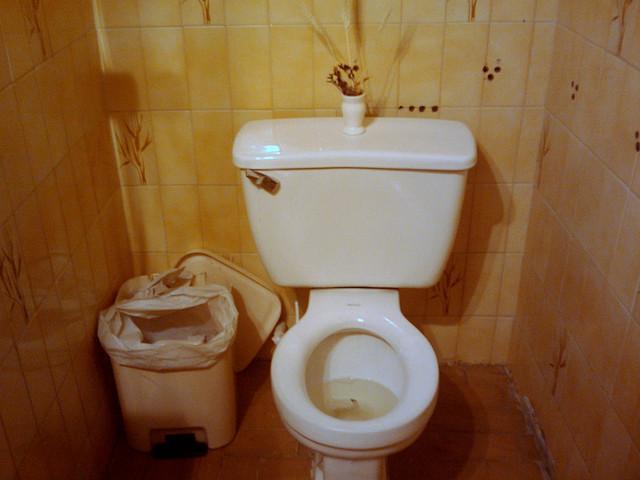How many people are not wearing a shirt?
Give a very brief answer. 0. 